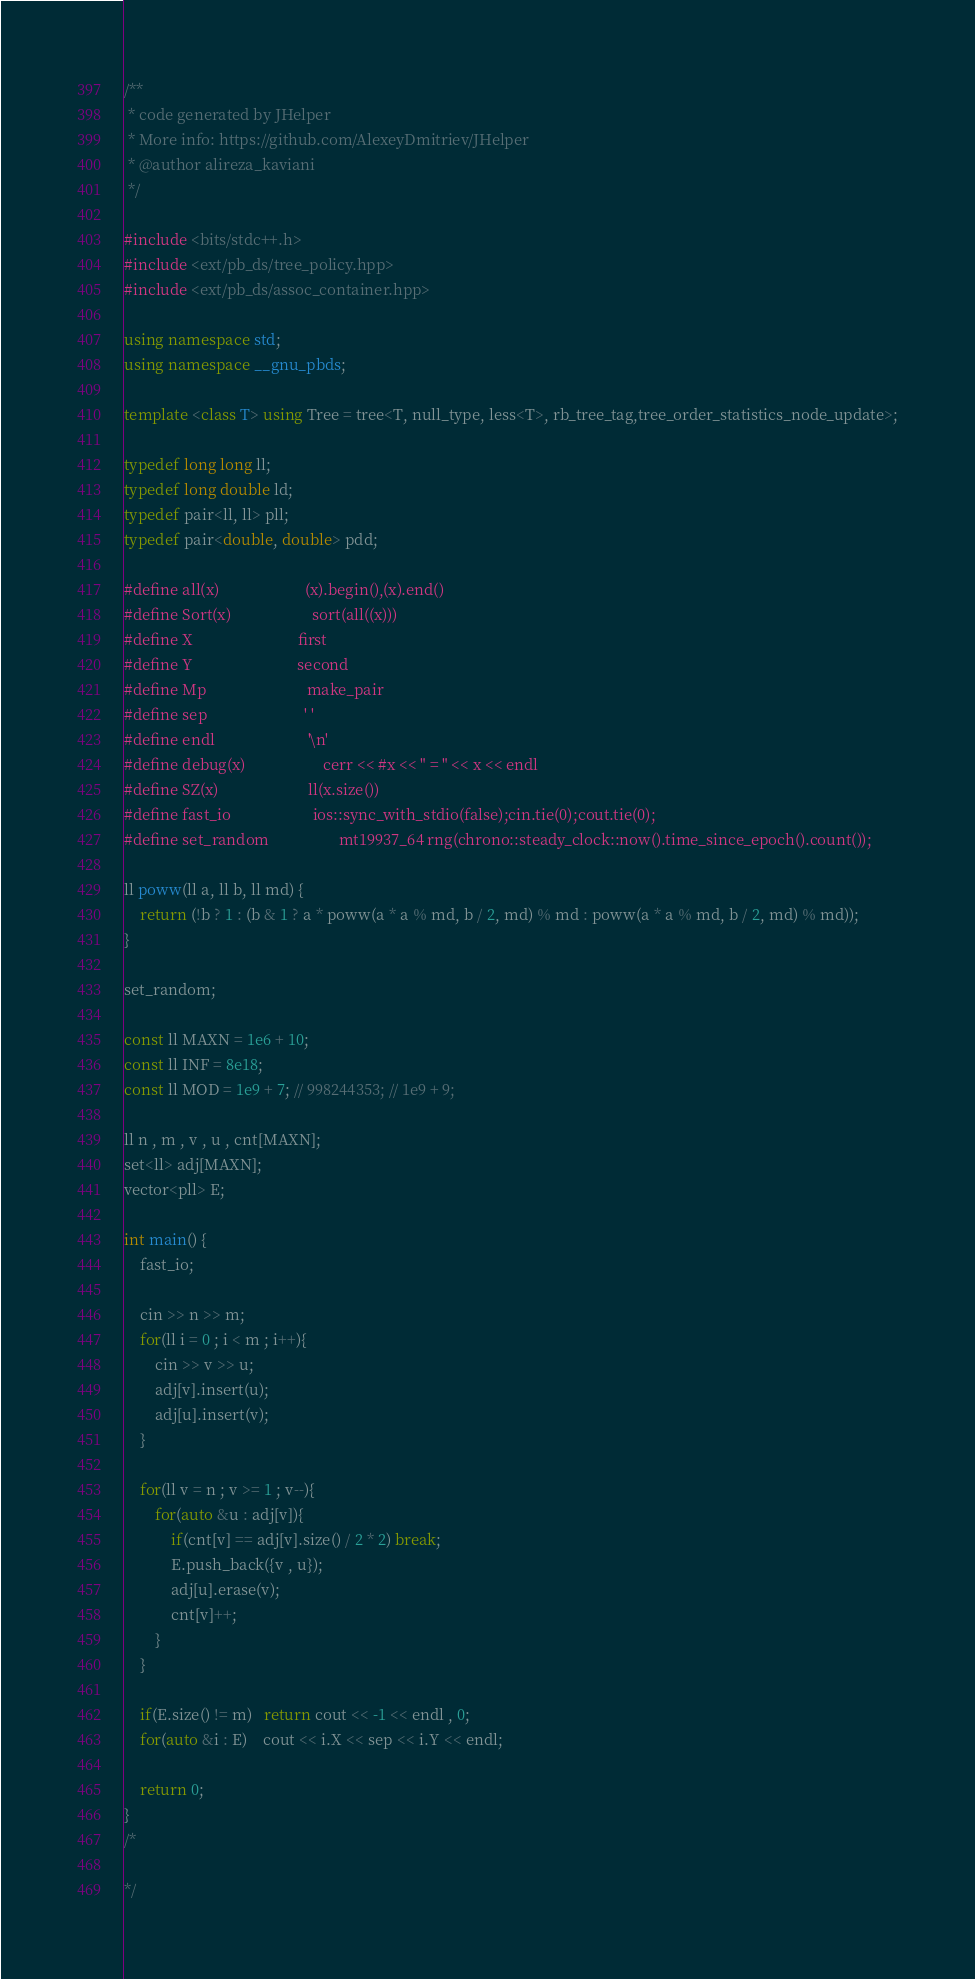Convert code to text. <code><loc_0><loc_0><loc_500><loc_500><_C++_>/**
 * code generated by JHelper
 * More info: https://github.com/AlexeyDmitriev/JHelper
 * @author alireza_kaviani
 */

#include <bits/stdc++.h>
#include <ext/pb_ds/tree_policy.hpp>
#include <ext/pb_ds/assoc_container.hpp>

using namespace std;
using namespace __gnu_pbds;

template <class T> using Tree = tree<T, null_type, less<T>, rb_tree_tag,tree_order_statistics_node_update>;

typedef long long ll;
typedef long double ld;
typedef pair<ll, ll> pll;
typedef pair<double, double> pdd;

#define all(x)                      (x).begin(),(x).end()
#define Sort(x)                     sort(all((x)))
#define X                           first
#define Y                           second
#define Mp                          make_pair
#define sep                         ' '
#define endl                        '\n'
#define debug(x)                    cerr << #x << " = " << x << endl
#define SZ(x)                       ll(x.size())
#define fast_io                     ios::sync_with_stdio(false);cin.tie(0);cout.tie(0);
#define set_random                  mt19937_64 rng(chrono::steady_clock::now().time_since_epoch().count());

ll poww(ll a, ll b, ll md) {
    return (!b ? 1 : (b & 1 ? a * poww(a * a % md, b / 2, md) % md : poww(a * a % md, b / 2, md) % md));
}

set_random;

const ll MAXN = 1e6 + 10;
const ll INF = 8e18;
const ll MOD = 1e9 + 7; // 998244353; // 1e9 + 9;

ll n , m , v , u , cnt[MAXN];
set<ll> adj[MAXN];
vector<pll> E;

int main() {
    fast_io;

    cin >> n >> m;
    for(ll i = 0 ; i < m ; i++){
        cin >> v >> u;
        adj[v].insert(u);
        adj[u].insert(v);
    }

    for(ll v = n ; v >= 1 ; v--){
        for(auto &u : adj[v]){
            if(cnt[v] == adj[v].size() / 2 * 2) break;
            E.push_back({v , u});
            adj[u].erase(v);
            cnt[v]++;
        }
    }

    if(E.size() != m)   return cout << -1 << endl , 0;
    for(auto &i : E)    cout << i.X << sep << i.Y << endl;

    return 0;
}
/*

*/
</code> 